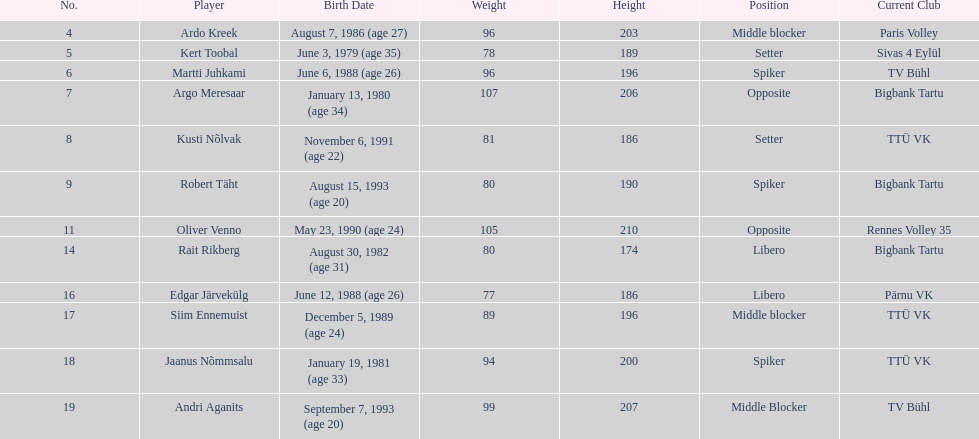How many members of estonia's men's national volleyball team were born in 1988? 2. 